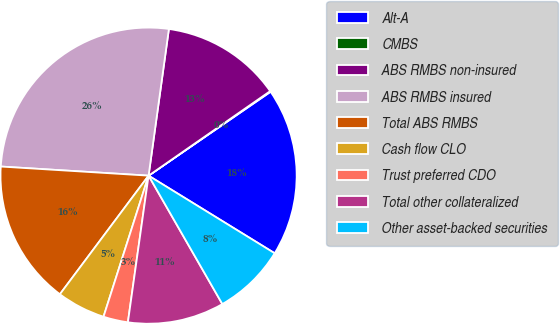Convert chart to OTSL. <chart><loc_0><loc_0><loc_500><loc_500><pie_chart><fcel>Alt-A<fcel>CMBS<fcel>ABS RMBS non-insured<fcel>ABS RMBS insured<fcel>Total ABS RMBS<fcel>Cash flow CLO<fcel>Trust preferred CDO<fcel>Total other collateralized<fcel>Other asset-backed securities<nl><fcel>18.37%<fcel>0.08%<fcel>13.14%<fcel>26.21%<fcel>15.76%<fcel>5.3%<fcel>2.69%<fcel>10.53%<fcel>7.92%<nl></chart> 